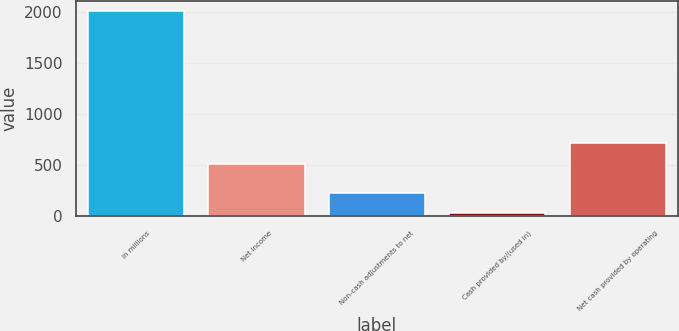Convert chart to OTSL. <chart><loc_0><loc_0><loc_500><loc_500><bar_chart><fcel>In millions<fcel>Net income<fcel>Non-cash adjustments to net<fcel>Cash provided by/(used in)<fcel>Net cash provided by operating<nl><fcel>2011<fcel>515.3<fcel>231.25<fcel>33.5<fcel>715.3<nl></chart> 